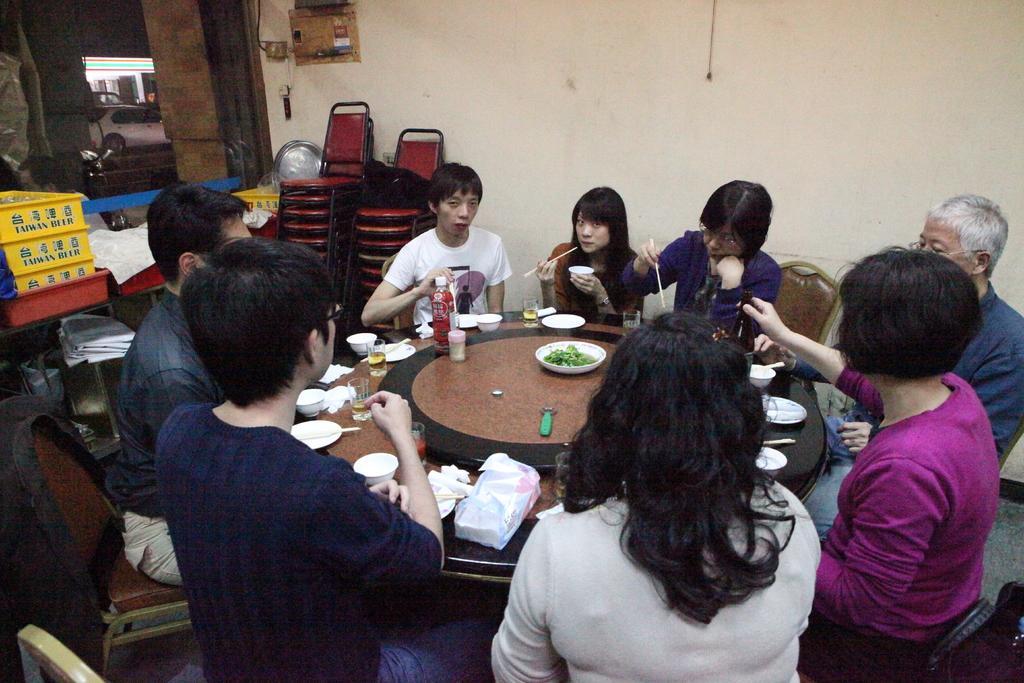Describe this image in one or two sentences. On the background we can see a wall and a socket. we can see empty chair here. Through window glass we can see a car. We can see all the persons sitting on chairs infront of a table and on the table we can see bottle, bowls, drinking glases, tissue papers, opener and green veggies ina bowl. 